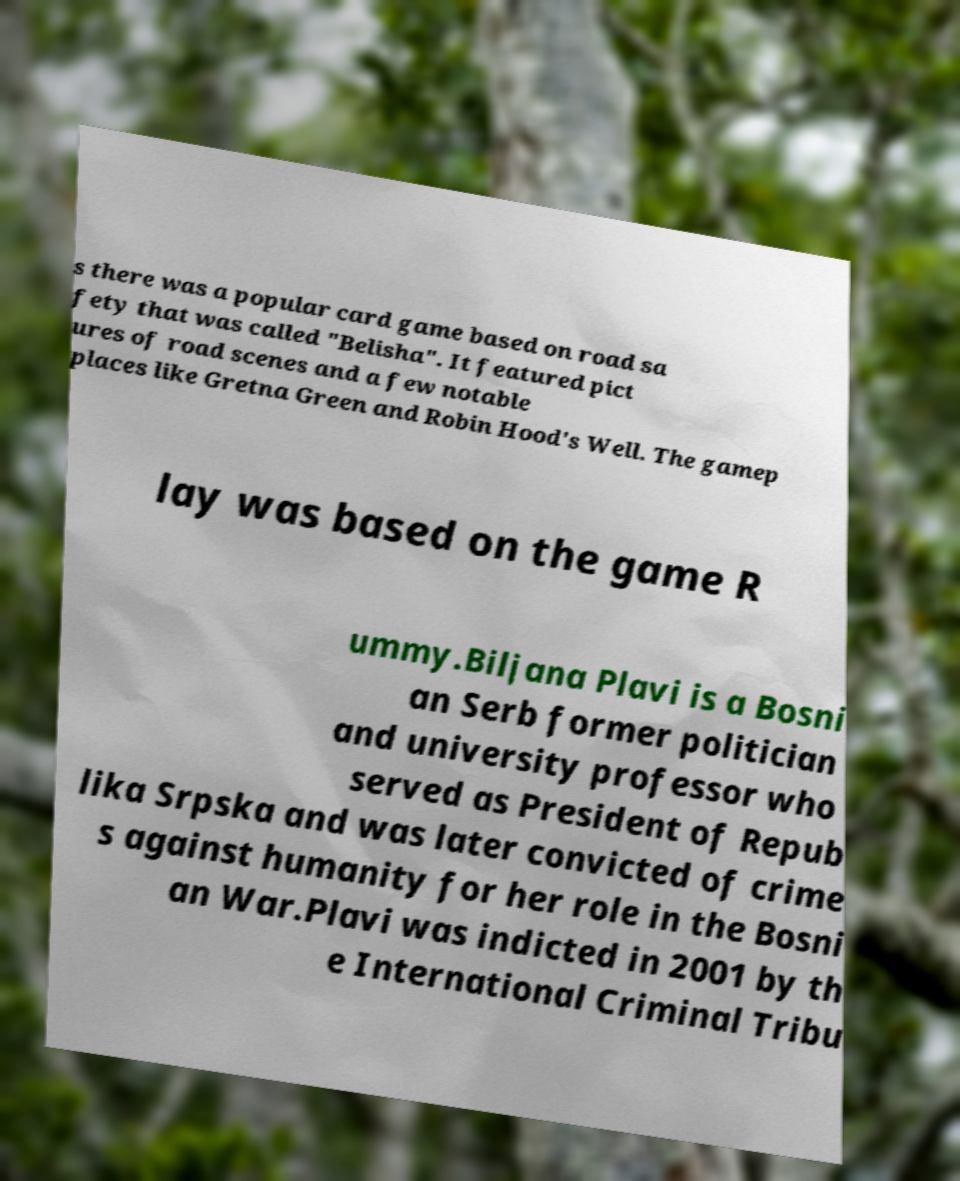What messages or text are displayed in this image? I need them in a readable, typed format. s there was a popular card game based on road sa fety that was called "Belisha". It featured pict ures of road scenes and a few notable places like Gretna Green and Robin Hood's Well. The gamep lay was based on the game R ummy.Biljana Plavi is a Bosni an Serb former politician and university professor who served as President of Repub lika Srpska and was later convicted of crime s against humanity for her role in the Bosni an War.Plavi was indicted in 2001 by th e International Criminal Tribu 